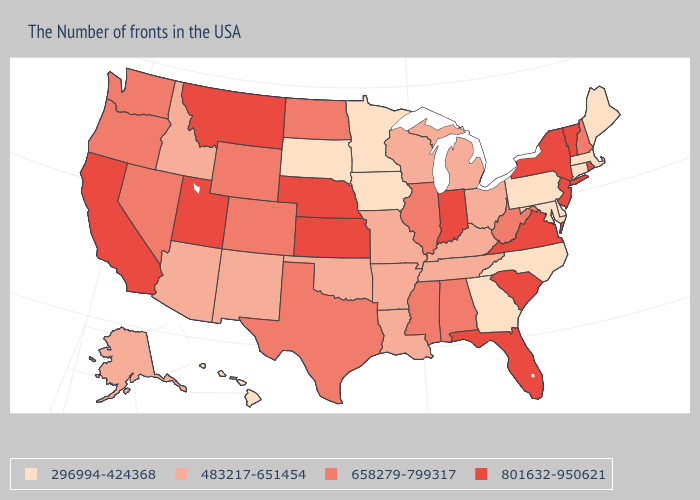What is the lowest value in states that border Missouri?
Write a very short answer. 296994-424368. Does the map have missing data?
Quick response, please. No. What is the highest value in the MidWest ?
Keep it brief. 801632-950621. What is the value of Maine?
Give a very brief answer. 296994-424368. Name the states that have a value in the range 658279-799317?
Quick response, please. New Hampshire, West Virginia, Alabama, Illinois, Mississippi, Texas, North Dakota, Wyoming, Colorado, Nevada, Washington, Oregon. What is the lowest value in the USA?
Concise answer only. 296994-424368. Does New Hampshire have a higher value than Minnesota?
Keep it brief. Yes. Name the states that have a value in the range 296994-424368?
Keep it brief. Maine, Massachusetts, Connecticut, Delaware, Maryland, Pennsylvania, North Carolina, Georgia, Minnesota, Iowa, South Dakota, Hawaii. What is the value of California?
Answer briefly. 801632-950621. Name the states that have a value in the range 483217-651454?
Be succinct. Ohio, Michigan, Kentucky, Tennessee, Wisconsin, Louisiana, Missouri, Arkansas, Oklahoma, New Mexico, Arizona, Idaho, Alaska. What is the value of Mississippi?
Give a very brief answer. 658279-799317. What is the value of Virginia?
Write a very short answer. 801632-950621. Which states hav the highest value in the West?
Quick response, please. Utah, Montana, California. Name the states that have a value in the range 801632-950621?
Be succinct. Rhode Island, Vermont, New York, New Jersey, Virginia, South Carolina, Florida, Indiana, Kansas, Nebraska, Utah, Montana, California. Does South Carolina have the highest value in the South?
Short answer required. Yes. 